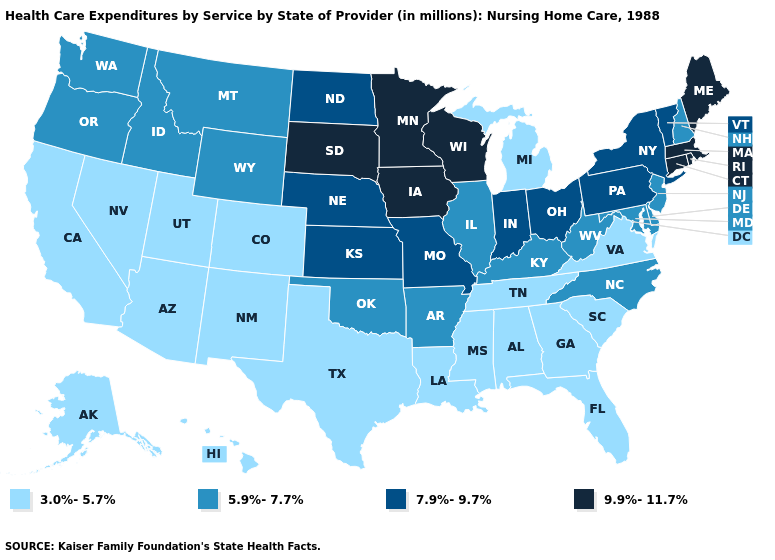Does Wisconsin have the lowest value in the USA?
Give a very brief answer. No. What is the value of Georgia?
Give a very brief answer. 3.0%-5.7%. Among the states that border Kentucky , does Virginia have the lowest value?
Give a very brief answer. Yes. Name the states that have a value in the range 5.9%-7.7%?
Be succinct. Arkansas, Delaware, Idaho, Illinois, Kentucky, Maryland, Montana, New Hampshire, New Jersey, North Carolina, Oklahoma, Oregon, Washington, West Virginia, Wyoming. Name the states that have a value in the range 5.9%-7.7%?
Be succinct. Arkansas, Delaware, Idaho, Illinois, Kentucky, Maryland, Montana, New Hampshire, New Jersey, North Carolina, Oklahoma, Oregon, Washington, West Virginia, Wyoming. Which states have the highest value in the USA?
Concise answer only. Connecticut, Iowa, Maine, Massachusetts, Minnesota, Rhode Island, South Dakota, Wisconsin. Which states have the lowest value in the MidWest?
Answer briefly. Michigan. Does the first symbol in the legend represent the smallest category?
Write a very short answer. Yes. What is the lowest value in the USA?
Write a very short answer. 3.0%-5.7%. Is the legend a continuous bar?
Quick response, please. No. What is the highest value in the USA?
Write a very short answer. 9.9%-11.7%. Does Idaho have the lowest value in the West?
Answer briefly. No. What is the highest value in states that border Maryland?
Short answer required. 7.9%-9.7%. Name the states that have a value in the range 5.9%-7.7%?
Give a very brief answer. Arkansas, Delaware, Idaho, Illinois, Kentucky, Maryland, Montana, New Hampshire, New Jersey, North Carolina, Oklahoma, Oregon, Washington, West Virginia, Wyoming. Does the map have missing data?
Short answer required. No. 